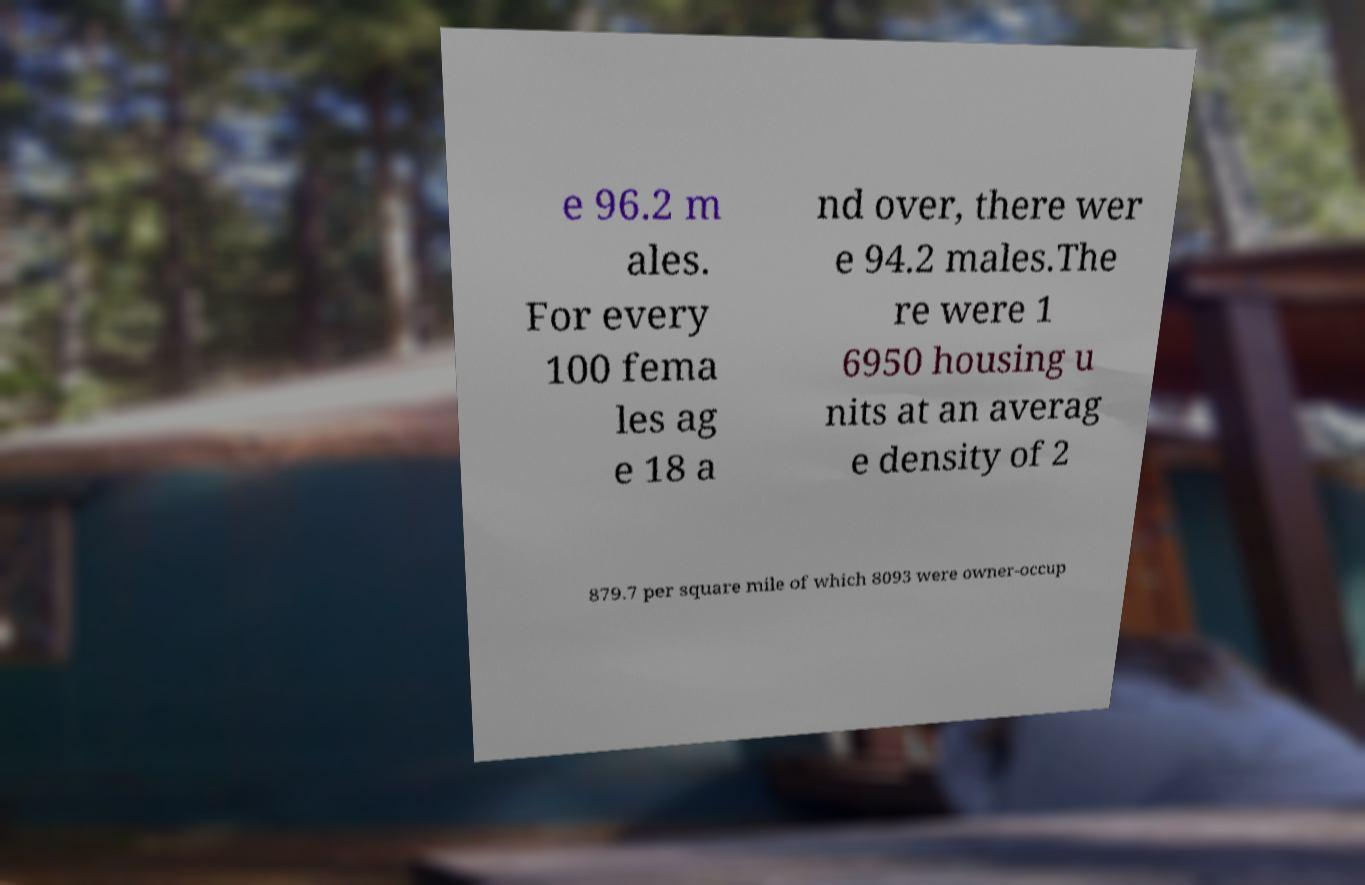I need the written content from this picture converted into text. Can you do that? e 96.2 m ales. For every 100 fema les ag e 18 a nd over, there wer e 94.2 males.The re were 1 6950 housing u nits at an averag e density of 2 879.7 per square mile of which 8093 were owner-occup 